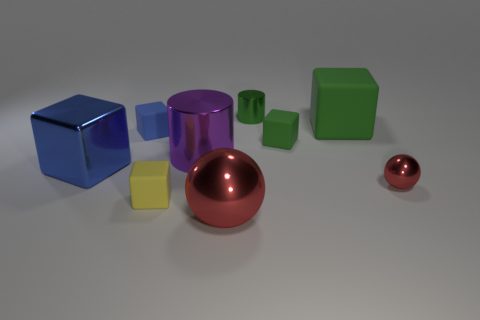Subtract all green blocks. How many were subtracted if there are1green blocks left? 1 Subtract all cylinders. How many objects are left? 7 Subtract 1 cylinders. How many cylinders are left? 1 Subtract all green cylinders. Subtract all cyan cubes. How many cylinders are left? 1 Subtract all green cubes. How many purple cylinders are left? 1 Subtract all brown blocks. Subtract all large green things. How many objects are left? 8 Add 2 tiny green metal objects. How many tiny green metal objects are left? 3 Add 8 small purple cylinders. How many small purple cylinders exist? 8 Add 1 purple metallic things. How many objects exist? 10 Subtract all green cubes. How many cubes are left? 3 